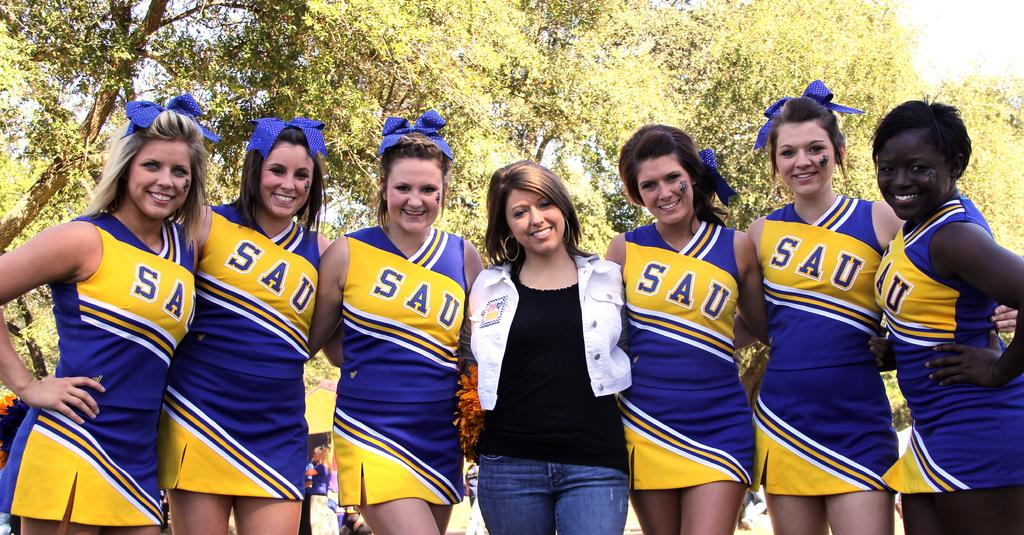<image>
Create a compact narrative representing the image presented. SAU cheerleaders are posing for the photo with a woman in jeans. 